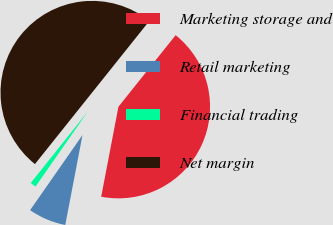Convert chart. <chart><loc_0><loc_0><loc_500><loc_500><pie_chart><fcel>Marketing storage and<fcel>Retail marketing<fcel>Financial trading<fcel>Net margin<nl><fcel>42.28%<fcel>6.68%<fcel>1.04%<fcel>50.0%<nl></chart> 